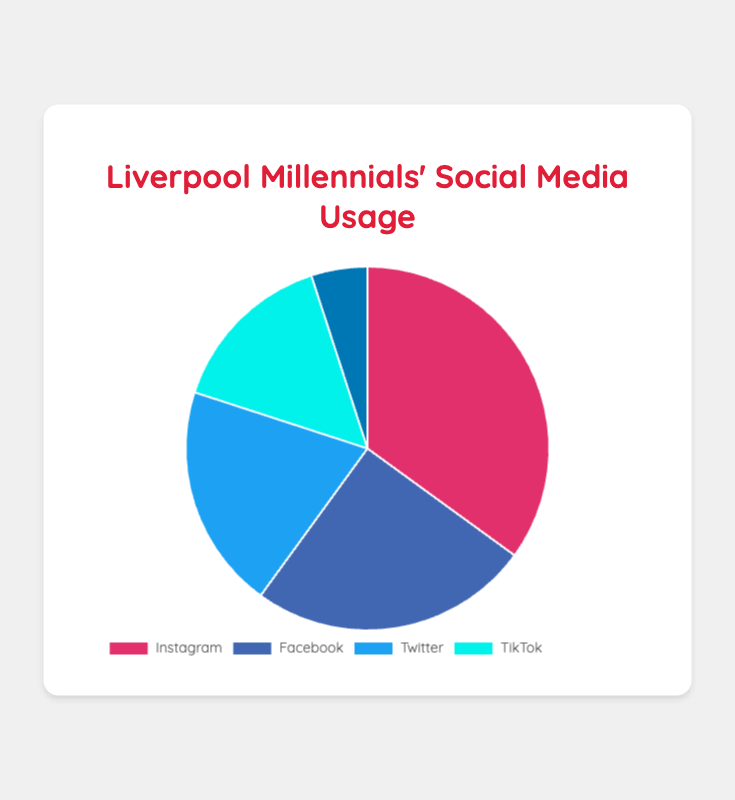What is the most popular social media platform among Liverpool millennials? The chart shows the percentage distribution of social media usage. Instagram has the highest at 35%.
Answer: Instagram Which social media platform is used the least by Liverpool millennials? The chart shows the percentage distribution of social media usage. LinkedIn has the lowest at 5%.
Answer: LinkedIn What is the combined percentage of millennials using Twitter and TikTok? The chart shows the percentages for Twitter and TikTok as 20% and 15%, respectively. Add them together: 20% + 15% = 35%.
Answer: 35% How does the usage percentage of Facebook compare to TikTok? The chart shows that Facebook has a usage of 25% and TikTok 15%. 25% is greater than 15%.
Answer: Facebook is more popular than TikTok What is the percentage difference between Instagram and Twitter usage? The chart shows the percentages for Instagram and Twitter as 35% and 20%, respectively. Subtract the smaller percentage from the larger: 35% - 20% = 15%.
Answer: 15% Which social media platform has a usage percentage closest to the average usage percentage? Average percentage = (35 + 25 + 20 + 15 + 5) / 5 = 20%. Twitter has a usage percentage of 20%, which matches the average.
Answer: Twitter Are there more millennials using Twitter and TikTok combined than those using Instagram alone? Combined usage of Twitter and TikTok = 20% + 15% = 35%. Instagram alone has a usage of 35%. They are equal.
Answer: No, they are equal What colors represent Facebook and LinkedIn in the pie chart? The chart uses colors to represent the platforms: Facebook is represented by blue, and LinkedIn is represented by a darker shade of blue.
Answer: Blue for Facebook and darker blue for LinkedIn How many platforms have a usage percentage greater than 20%? The chart shows that Instagram (35%) and Facebook (25%) both have percentages greater than 20%. So there are 2 platforms.
Answer: 2 